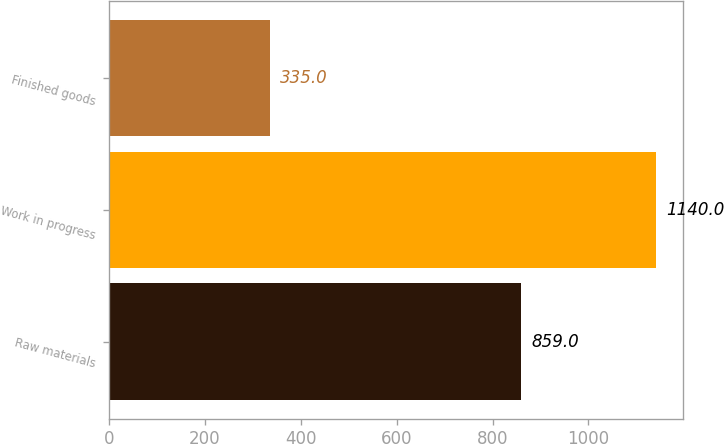Convert chart. <chart><loc_0><loc_0><loc_500><loc_500><bar_chart><fcel>Raw materials<fcel>Work in progress<fcel>Finished goods<nl><fcel>859<fcel>1140<fcel>335<nl></chart> 